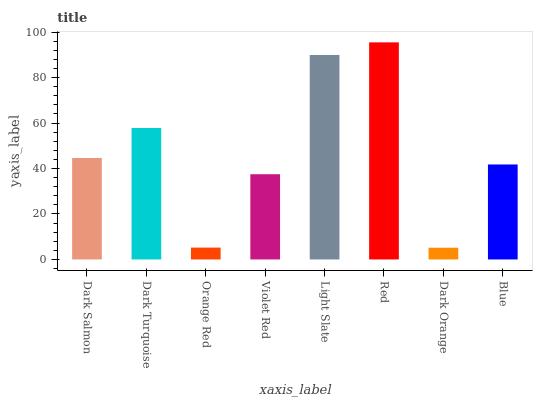Is Dark Orange the minimum?
Answer yes or no. Yes. Is Red the maximum?
Answer yes or no. Yes. Is Dark Turquoise the minimum?
Answer yes or no. No. Is Dark Turquoise the maximum?
Answer yes or no. No. Is Dark Turquoise greater than Dark Salmon?
Answer yes or no. Yes. Is Dark Salmon less than Dark Turquoise?
Answer yes or no. Yes. Is Dark Salmon greater than Dark Turquoise?
Answer yes or no. No. Is Dark Turquoise less than Dark Salmon?
Answer yes or no. No. Is Dark Salmon the high median?
Answer yes or no. Yes. Is Blue the low median?
Answer yes or no. Yes. Is Light Slate the high median?
Answer yes or no. No. Is Light Slate the low median?
Answer yes or no. No. 